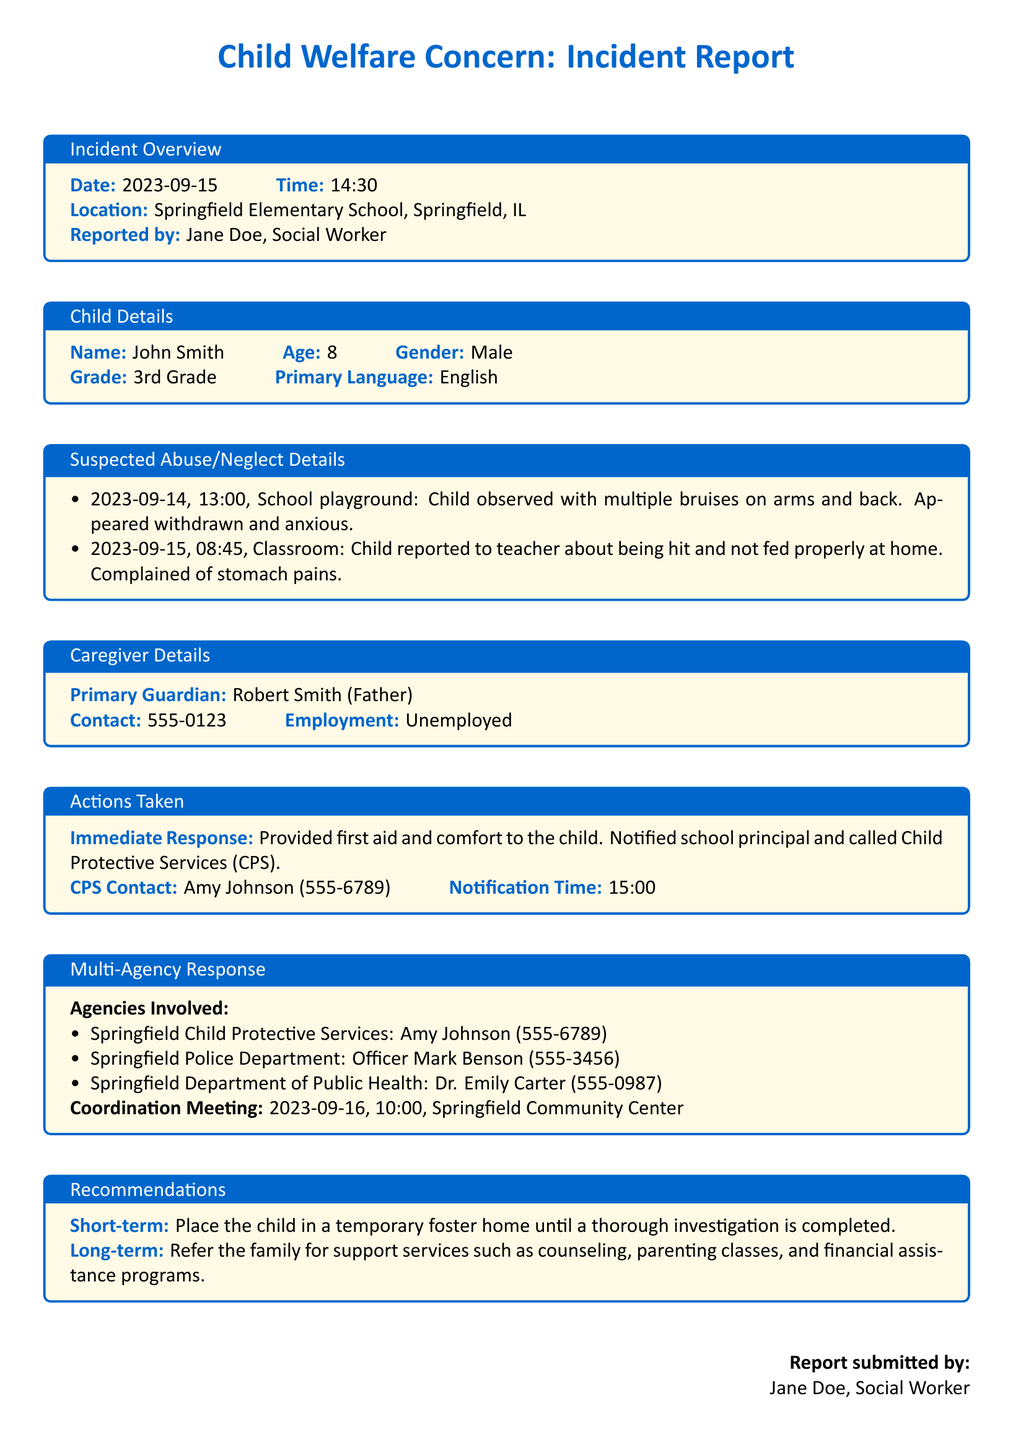what is the date of the incident? The date of the incident is found in the incident overview section of the document.
Answer: 2023-09-15 who reported the incident? The name of the person who reported the incident is indicated under the incident overview.
Answer: Jane Doe what is the child's primary language? The primary language of the child is detailed in the child details section.
Answer: English what action was taken immediately after the incident? The immediate response is described in the actions taken section.
Answer: Provided first aid and comfort to the child which agency is responsible for the investigation? The agency responsible for investigating the reported concerns is listed in the multi-agency response section.
Answer: Springfield Child Protective Services how many bruise observations were noted? The number of times bruises were mentioned in the suspected abuse/neglect details needs to be counted.
Answer: multiple what is the long-term recommendation for the family? The long-term recommendation is stated specifically in the recommendations section of the report.
Answer: Refer the family for support services such as counseling, parenting classes, and financial assistance programs where was the coordination meeting scheduled? The location of the coordination meeting is found in the multi-agency response section.
Answer: Springfield Community Center 